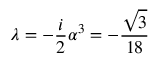Convert formula to latex. <formula><loc_0><loc_0><loc_500><loc_500>\lambda = - \frac { i } { 2 } \alpha ^ { 3 } = - \frac { \sqrt { 3 } } { 1 8 }</formula> 